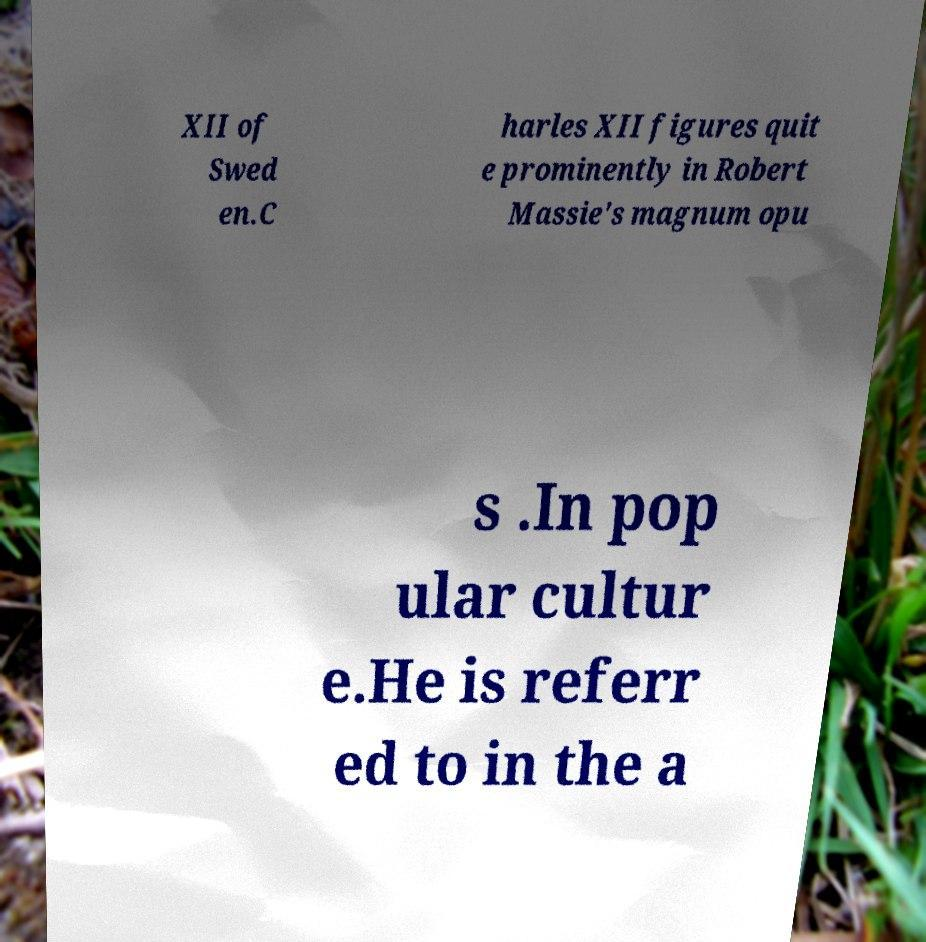Could you extract and type out the text from this image? XII of Swed en.C harles XII figures quit e prominently in Robert Massie's magnum opu s .In pop ular cultur e.He is referr ed to in the a 